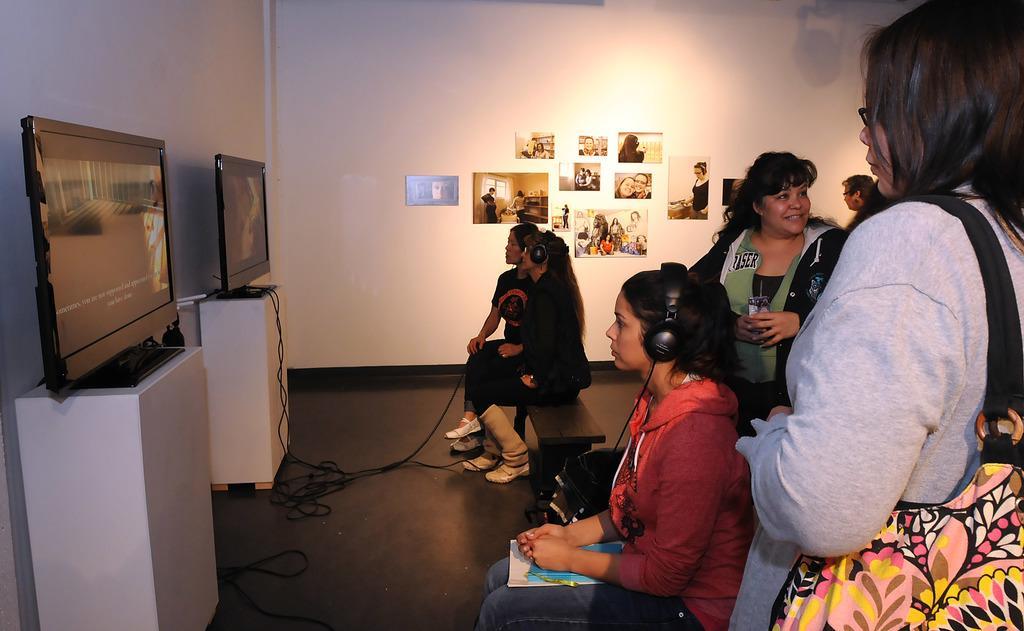Could you give a brief overview of what you see in this image? In this image there are three women sitting on the bench, there are two women wearing headphones, there is floor towards the bottom of the image, there are monitors, there are wires, there are three women standing, there is a woman holding an object, there is a wall towards the top of the image, there are photo frames on the wall. 